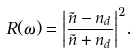<formula> <loc_0><loc_0><loc_500><loc_500>R ( \omega ) = { \left | { \frac { \tilde { n } - n _ { d } } { \tilde { n } + n _ { d } } } \right | } ^ { 2 } .</formula> 